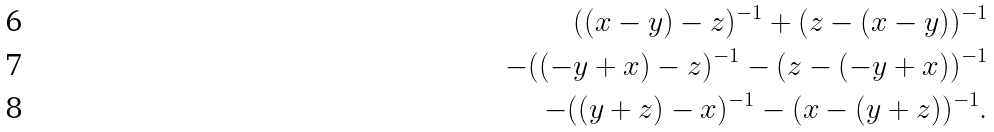<formula> <loc_0><loc_0><loc_500><loc_500>( ( x - y ) - z ) ^ { - 1 } + ( z - ( x - y ) ) ^ { - 1 } \\ - ( ( - y + x ) - z ) ^ { - 1 } - ( z - ( - y + x ) ) ^ { - 1 } \\ - ( ( y + z ) - x ) ^ { - 1 } - ( x - ( y + z ) ) ^ { - 1 } .</formula> 